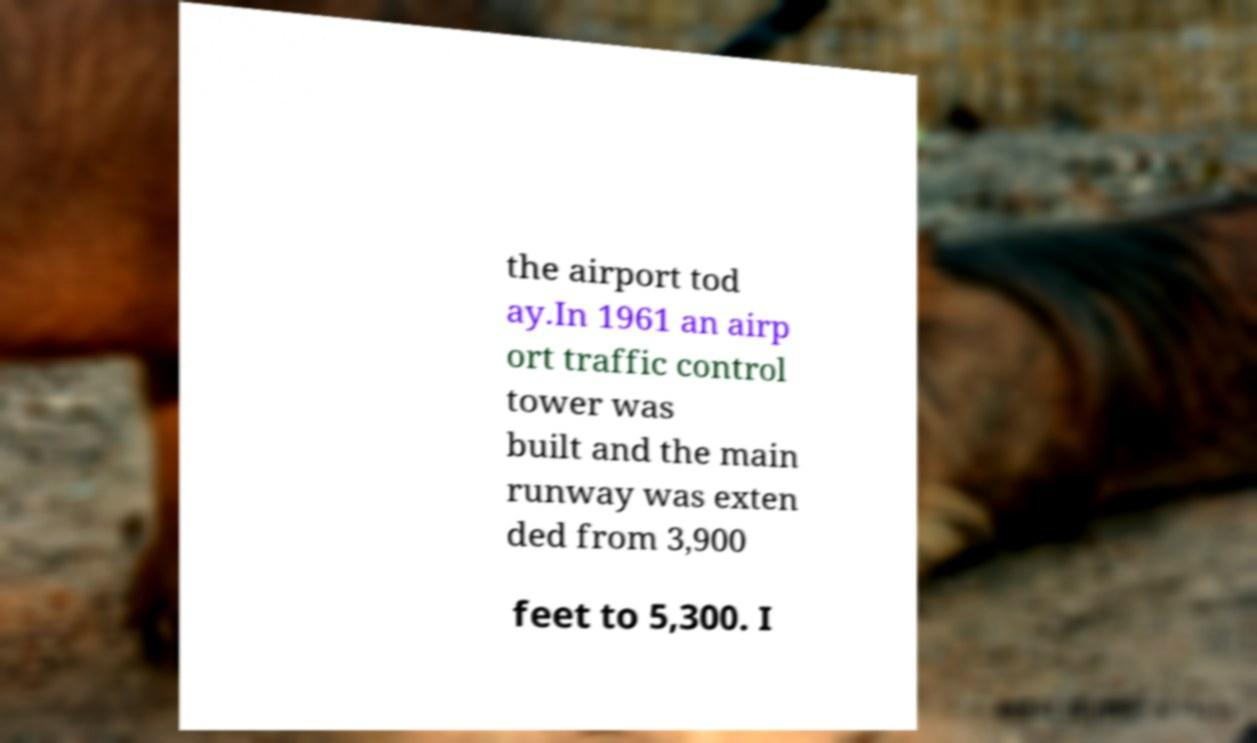Can you accurately transcribe the text from the provided image for me? the airport tod ay.In 1961 an airp ort traffic control tower was built and the main runway was exten ded from 3,900 feet to 5,300. I 